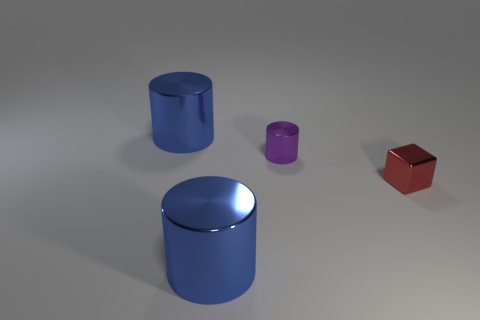Add 1 small purple objects. How many objects exist? 5 Subtract all cylinders. How many objects are left? 1 Add 4 big gray matte cylinders. How many big gray matte cylinders exist? 4 Subtract 0 gray balls. How many objects are left? 4 Subtract all cyan matte blocks. Subtract all metal cylinders. How many objects are left? 1 Add 4 tiny red blocks. How many tiny red blocks are left? 5 